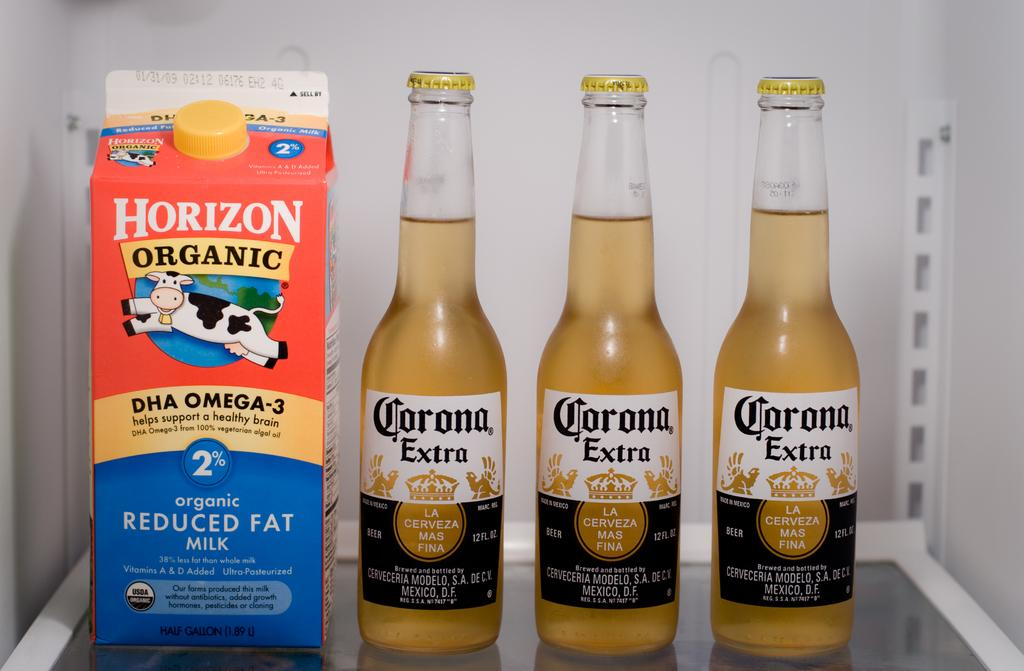<image>
Summarize the visual content of the image. A carton of horizon organic milk is next to 3 bottle of corona on the shelf. 